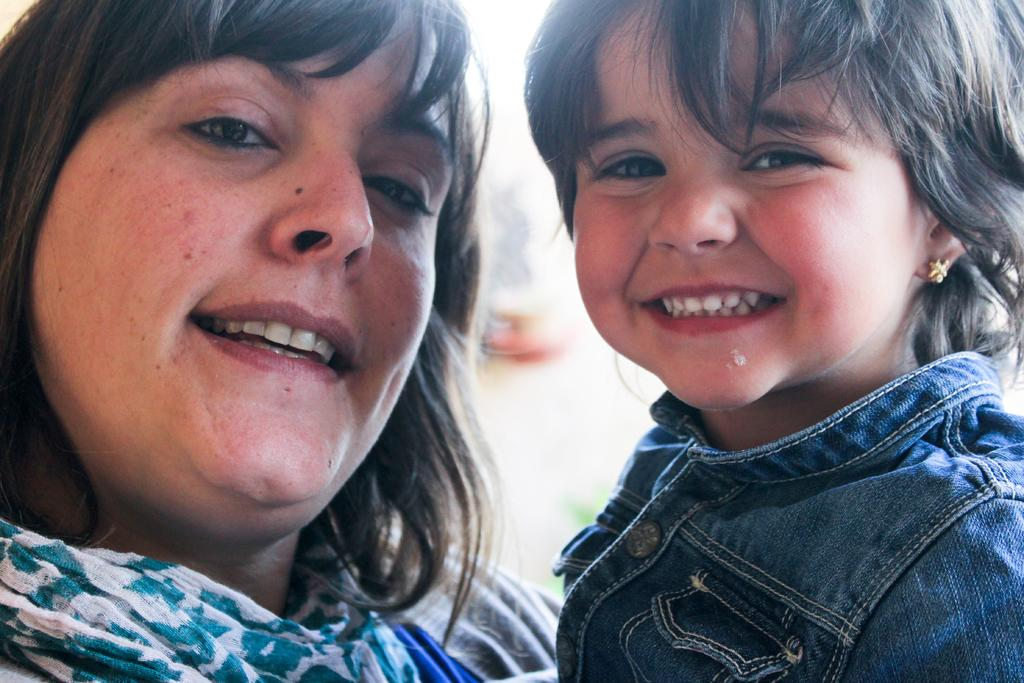Who is present in the image? There is a woman and a girl in the image. What are the expressions on their faces? Both the woman and the girl are smiling. Can you describe the background of the image? The background of the image is blurred. What accessory is the girl wearing? The girl is wearing an earring. What type of whip is being advertised in the image? There is no whip or advertisement present in the image. What kind of cart is visible in the background of the image? There is no cart visible in the image; the background is blurred. 